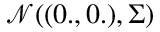Convert formula to latex. <formula><loc_0><loc_0><loc_500><loc_500>\mathcal { N } ( ( 0 . , 0 . ) , \Sigma )</formula> 